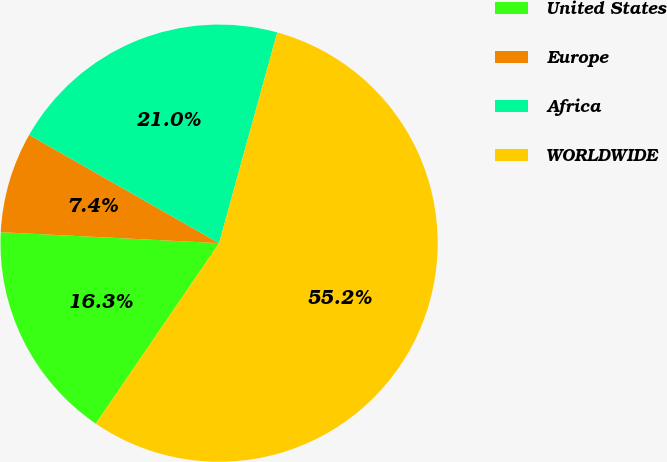Convert chart to OTSL. <chart><loc_0><loc_0><loc_500><loc_500><pie_chart><fcel>United States<fcel>Europe<fcel>Africa<fcel>WORLDWIDE<nl><fcel>16.26%<fcel>7.45%<fcel>21.04%<fcel>55.25%<nl></chart> 